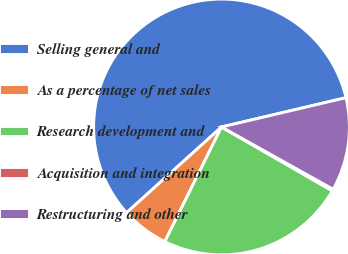Convert chart. <chart><loc_0><loc_0><loc_500><loc_500><pie_chart><fcel>Selling general and<fcel>As a percentage of net sales<fcel>Research development and<fcel>Acquisition and integration<fcel>Restructuring and other<nl><fcel>58.01%<fcel>6.0%<fcel>23.99%<fcel>0.22%<fcel>11.78%<nl></chart> 